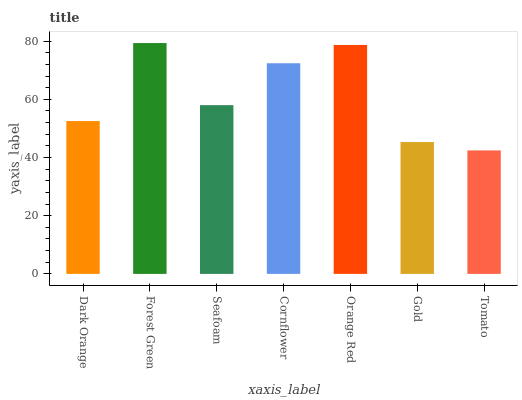Is Seafoam the minimum?
Answer yes or no. No. Is Seafoam the maximum?
Answer yes or no. No. Is Forest Green greater than Seafoam?
Answer yes or no. Yes. Is Seafoam less than Forest Green?
Answer yes or no. Yes. Is Seafoam greater than Forest Green?
Answer yes or no. No. Is Forest Green less than Seafoam?
Answer yes or no. No. Is Seafoam the high median?
Answer yes or no. Yes. Is Seafoam the low median?
Answer yes or no. Yes. Is Forest Green the high median?
Answer yes or no. No. Is Dark Orange the low median?
Answer yes or no. No. 